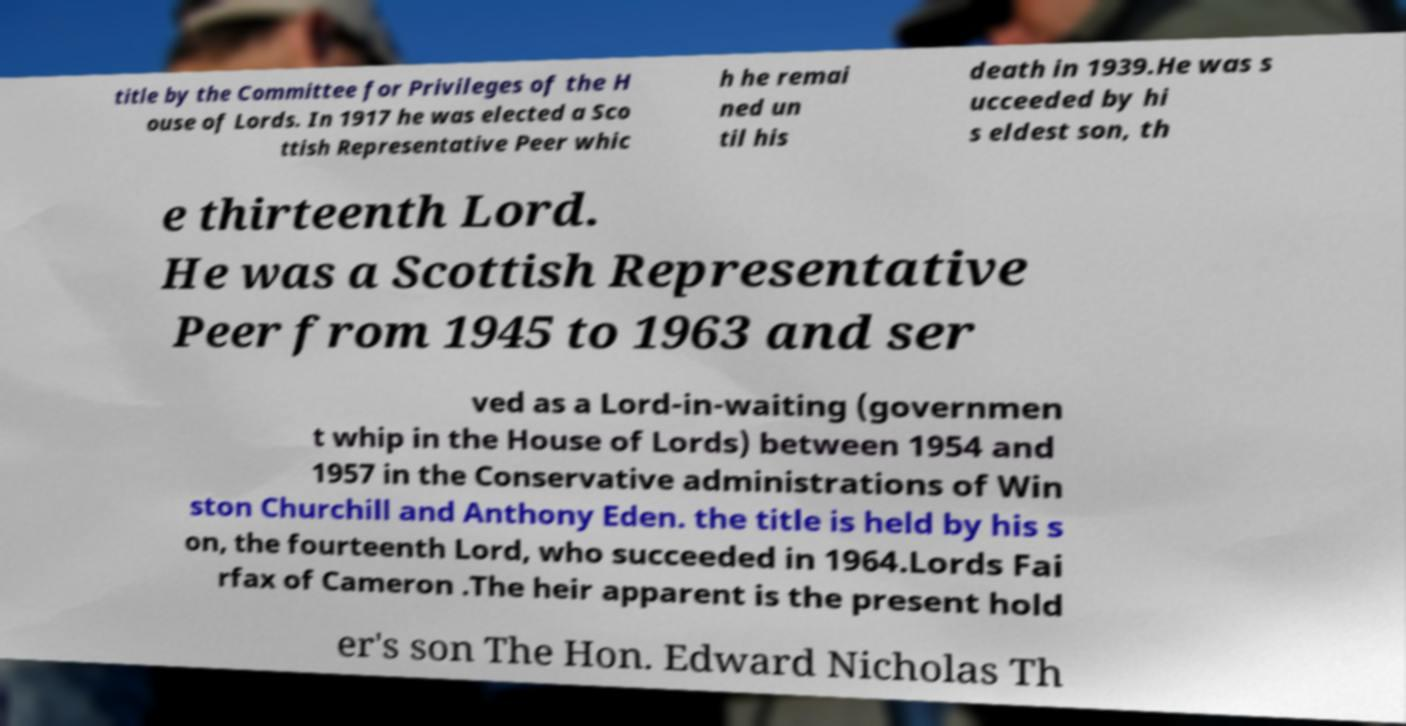For documentation purposes, I need the text within this image transcribed. Could you provide that? title by the Committee for Privileges of the H ouse of Lords. In 1917 he was elected a Sco ttish Representative Peer whic h he remai ned un til his death in 1939.He was s ucceeded by hi s eldest son, th e thirteenth Lord. He was a Scottish Representative Peer from 1945 to 1963 and ser ved as a Lord-in-waiting (governmen t whip in the House of Lords) between 1954 and 1957 in the Conservative administrations of Win ston Churchill and Anthony Eden. the title is held by his s on, the fourteenth Lord, who succeeded in 1964.Lords Fai rfax of Cameron .The heir apparent is the present hold er's son The Hon. Edward Nicholas Th 